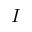<formula> <loc_0><loc_0><loc_500><loc_500>I</formula> 